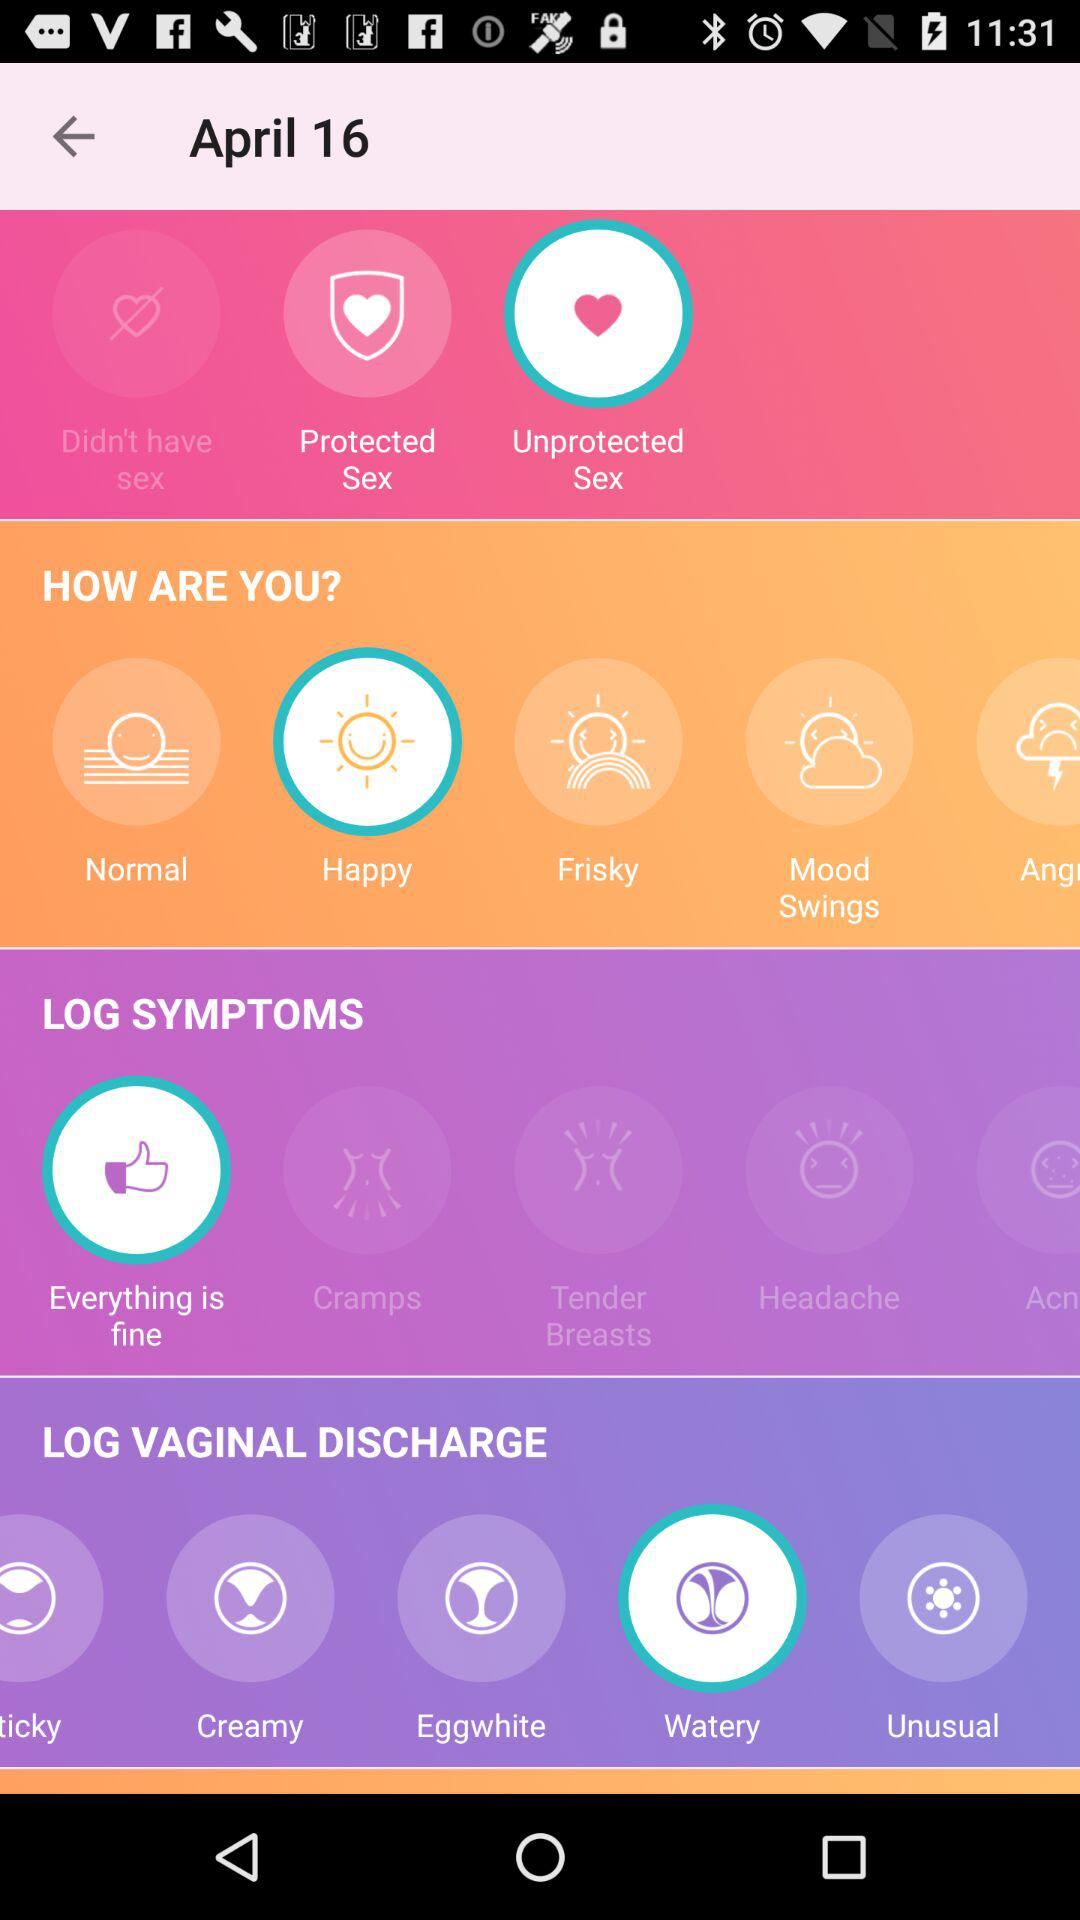Which option is selected in "HOW ARE YOU?"? The selected option is "Happy". 